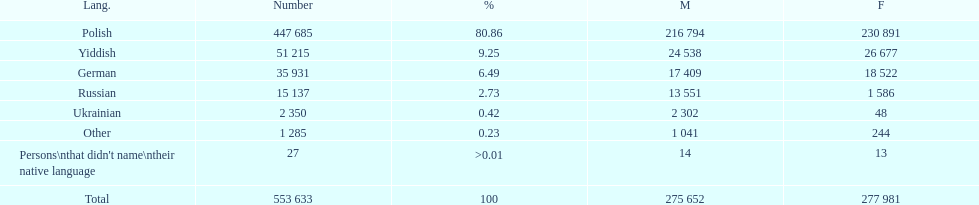Which language did the most people in the imperial census of 1897 speak in the p&#322;ock governorate? Polish. 